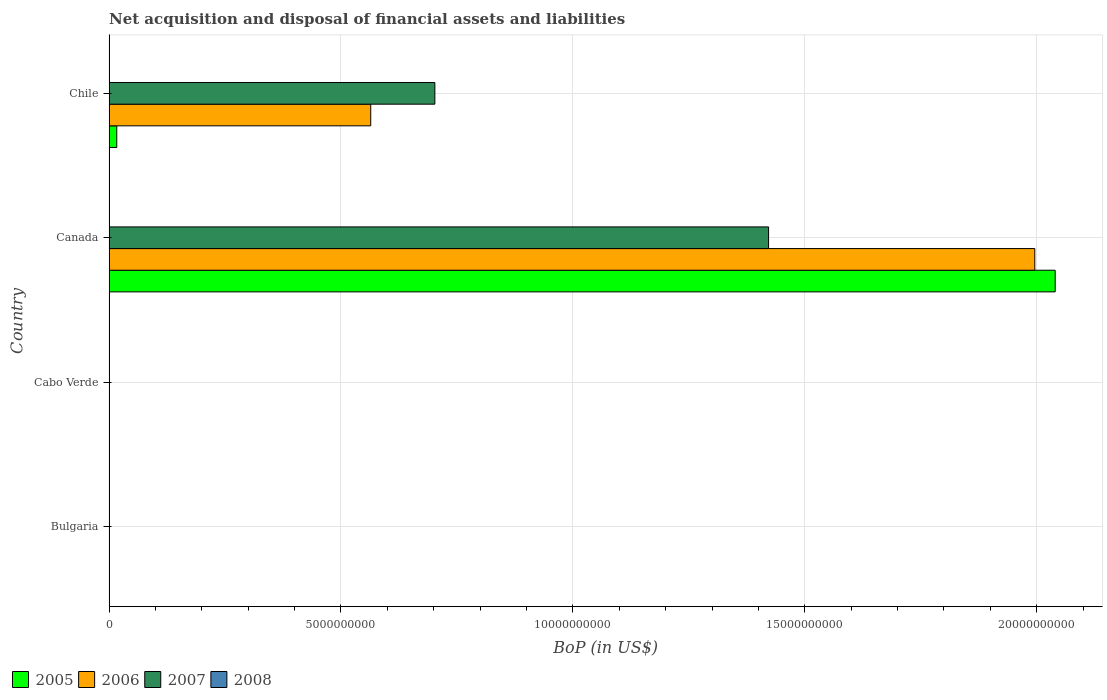Are the number of bars per tick equal to the number of legend labels?
Provide a short and direct response. No. Are the number of bars on each tick of the Y-axis equal?
Your answer should be very brief. No. How many bars are there on the 2nd tick from the bottom?
Make the answer very short. 0. What is the label of the 4th group of bars from the top?
Provide a succinct answer. Bulgaria. What is the Balance of Payments in 2005 in Canada?
Offer a terse response. 2.04e+1. Across all countries, what is the maximum Balance of Payments in 2007?
Give a very brief answer. 1.42e+1. What is the total Balance of Payments in 2005 in the graph?
Offer a terse response. 2.06e+1. What is the difference between the Balance of Payments in 2006 in Canada and that in Chile?
Provide a succinct answer. 1.43e+1. What is the difference between the Balance of Payments in 2008 in Chile and the Balance of Payments in 2005 in Canada?
Provide a short and direct response. -2.04e+1. What is the average Balance of Payments in 2006 per country?
Your response must be concise. 6.40e+09. What is the difference between the Balance of Payments in 2005 and Balance of Payments in 2006 in Chile?
Offer a very short reply. -5.48e+09. In how many countries, is the Balance of Payments in 2008 greater than 3000000000 US$?
Offer a very short reply. 0. What is the ratio of the Balance of Payments in 2006 in Canada to that in Chile?
Provide a short and direct response. 3.54. What is the difference between the highest and the lowest Balance of Payments in 2006?
Provide a succinct answer. 2.00e+1. In how many countries, is the Balance of Payments in 2006 greater than the average Balance of Payments in 2006 taken over all countries?
Provide a succinct answer. 1. Is the sum of the Balance of Payments in 2005 in Canada and Chile greater than the maximum Balance of Payments in 2008 across all countries?
Make the answer very short. Yes. Is it the case that in every country, the sum of the Balance of Payments in 2007 and Balance of Payments in 2006 is greater than the sum of Balance of Payments in 2005 and Balance of Payments in 2008?
Offer a terse response. No. How many countries are there in the graph?
Your answer should be very brief. 4. Are the values on the major ticks of X-axis written in scientific E-notation?
Make the answer very short. No. Does the graph contain any zero values?
Ensure brevity in your answer.  Yes. Where does the legend appear in the graph?
Provide a short and direct response. Bottom left. What is the title of the graph?
Provide a short and direct response. Net acquisition and disposal of financial assets and liabilities. What is the label or title of the X-axis?
Your answer should be compact. BoP (in US$). What is the label or title of the Y-axis?
Offer a terse response. Country. What is the BoP (in US$) of 2005 in Bulgaria?
Keep it short and to the point. 0. What is the BoP (in US$) in 2006 in Bulgaria?
Provide a succinct answer. 0. What is the BoP (in US$) of 2007 in Bulgaria?
Your answer should be very brief. 0. What is the BoP (in US$) of 2006 in Cabo Verde?
Make the answer very short. 0. What is the BoP (in US$) in 2008 in Cabo Verde?
Ensure brevity in your answer.  0. What is the BoP (in US$) of 2005 in Canada?
Your answer should be compact. 2.04e+1. What is the BoP (in US$) of 2006 in Canada?
Keep it short and to the point. 2.00e+1. What is the BoP (in US$) in 2007 in Canada?
Provide a short and direct response. 1.42e+1. What is the BoP (in US$) of 2008 in Canada?
Ensure brevity in your answer.  0. What is the BoP (in US$) in 2005 in Chile?
Provide a succinct answer. 1.66e+08. What is the BoP (in US$) of 2006 in Chile?
Ensure brevity in your answer.  5.64e+09. What is the BoP (in US$) of 2007 in Chile?
Provide a short and direct response. 7.02e+09. What is the BoP (in US$) in 2008 in Chile?
Give a very brief answer. 0. Across all countries, what is the maximum BoP (in US$) in 2005?
Your answer should be compact. 2.04e+1. Across all countries, what is the maximum BoP (in US$) in 2006?
Keep it short and to the point. 2.00e+1. Across all countries, what is the maximum BoP (in US$) in 2007?
Offer a terse response. 1.42e+1. Across all countries, what is the minimum BoP (in US$) in 2005?
Your answer should be very brief. 0. Across all countries, what is the minimum BoP (in US$) of 2006?
Your answer should be compact. 0. What is the total BoP (in US$) in 2005 in the graph?
Ensure brevity in your answer.  2.06e+1. What is the total BoP (in US$) of 2006 in the graph?
Your answer should be compact. 2.56e+1. What is the total BoP (in US$) of 2007 in the graph?
Ensure brevity in your answer.  2.12e+1. What is the difference between the BoP (in US$) of 2005 in Canada and that in Chile?
Provide a succinct answer. 2.02e+1. What is the difference between the BoP (in US$) in 2006 in Canada and that in Chile?
Keep it short and to the point. 1.43e+1. What is the difference between the BoP (in US$) in 2007 in Canada and that in Chile?
Provide a short and direct response. 7.19e+09. What is the difference between the BoP (in US$) in 2005 in Canada and the BoP (in US$) in 2006 in Chile?
Your response must be concise. 1.48e+1. What is the difference between the BoP (in US$) in 2005 in Canada and the BoP (in US$) in 2007 in Chile?
Your answer should be compact. 1.34e+1. What is the difference between the BoP (in US$) in 2006 in Canada and the BoP (in US$) in 2007 in Chile?
Your answer should be very brief. 1.29e+1. What is the average BoP (in US$) in 2005 per country?
Offer a very short reply. 5.14e+09. What is the average BoP (in US$) of 2006 per country?
Make the answer very short. 6.40e+09. What is the average BoP (in US$) in 2007 per country?
Give a very brief answer. 5.31e+09. What is the difference between the BoP (in US$) of 2005 and BoP (in US$) of 2006 in Canada?
Make the answer very short. 4.40e+08. What is the difference between the BoP (in US$) of 2005 and BoP (in US$) of 2007 in Canada?
Your response must be concise. 6.18e+09. What is the difference between the BoP (in US$) of 2006 and BoP (in US$) of 2007 in Canada?
Your response must be concise. 5.74e+09. What is the difference between the BoP (in US$) of 2005 and BoP (in US$) of 2006 in Chile?
Make the answer very short. -5.48e+09. What is the difference between the BoP (in US$) of 2005 and BoP (in US$) of 2007 in Chile?
Ensure brevity in your answer.  -6.86e+09. What is the difference between the BoP (in US$) of 2006 and BoP (in US$) of 2007 in Chile?
Make the answer very short. -1.38e+09. What is the ratio of the BoP (in US$) of 2005 in Canada to that in Chile?
Your answer should be very brief. 122.81. What is the ratio of the BoP (in US$) of 2006 in Canada to that in Chile?
Ensure brevity in your answer.  3.54. What is the ratio of the BoP (in US$) in 2007 in Canada to that in Chile?
Provide a short and direct response. 2.02. What is the difference between the highest and the lowest BoP (in US$) in 2005?
Your answer should be very brief. 2.04e+1. What is the difference between the highest and the lowest BoP (in US$) of 2006?
Your answer should be very brief. 2.00e+1. What is the difference between the highest and the lowest BoP (in US$) of 2007?
Ensure brevity in your answer.  1.42e+1. 